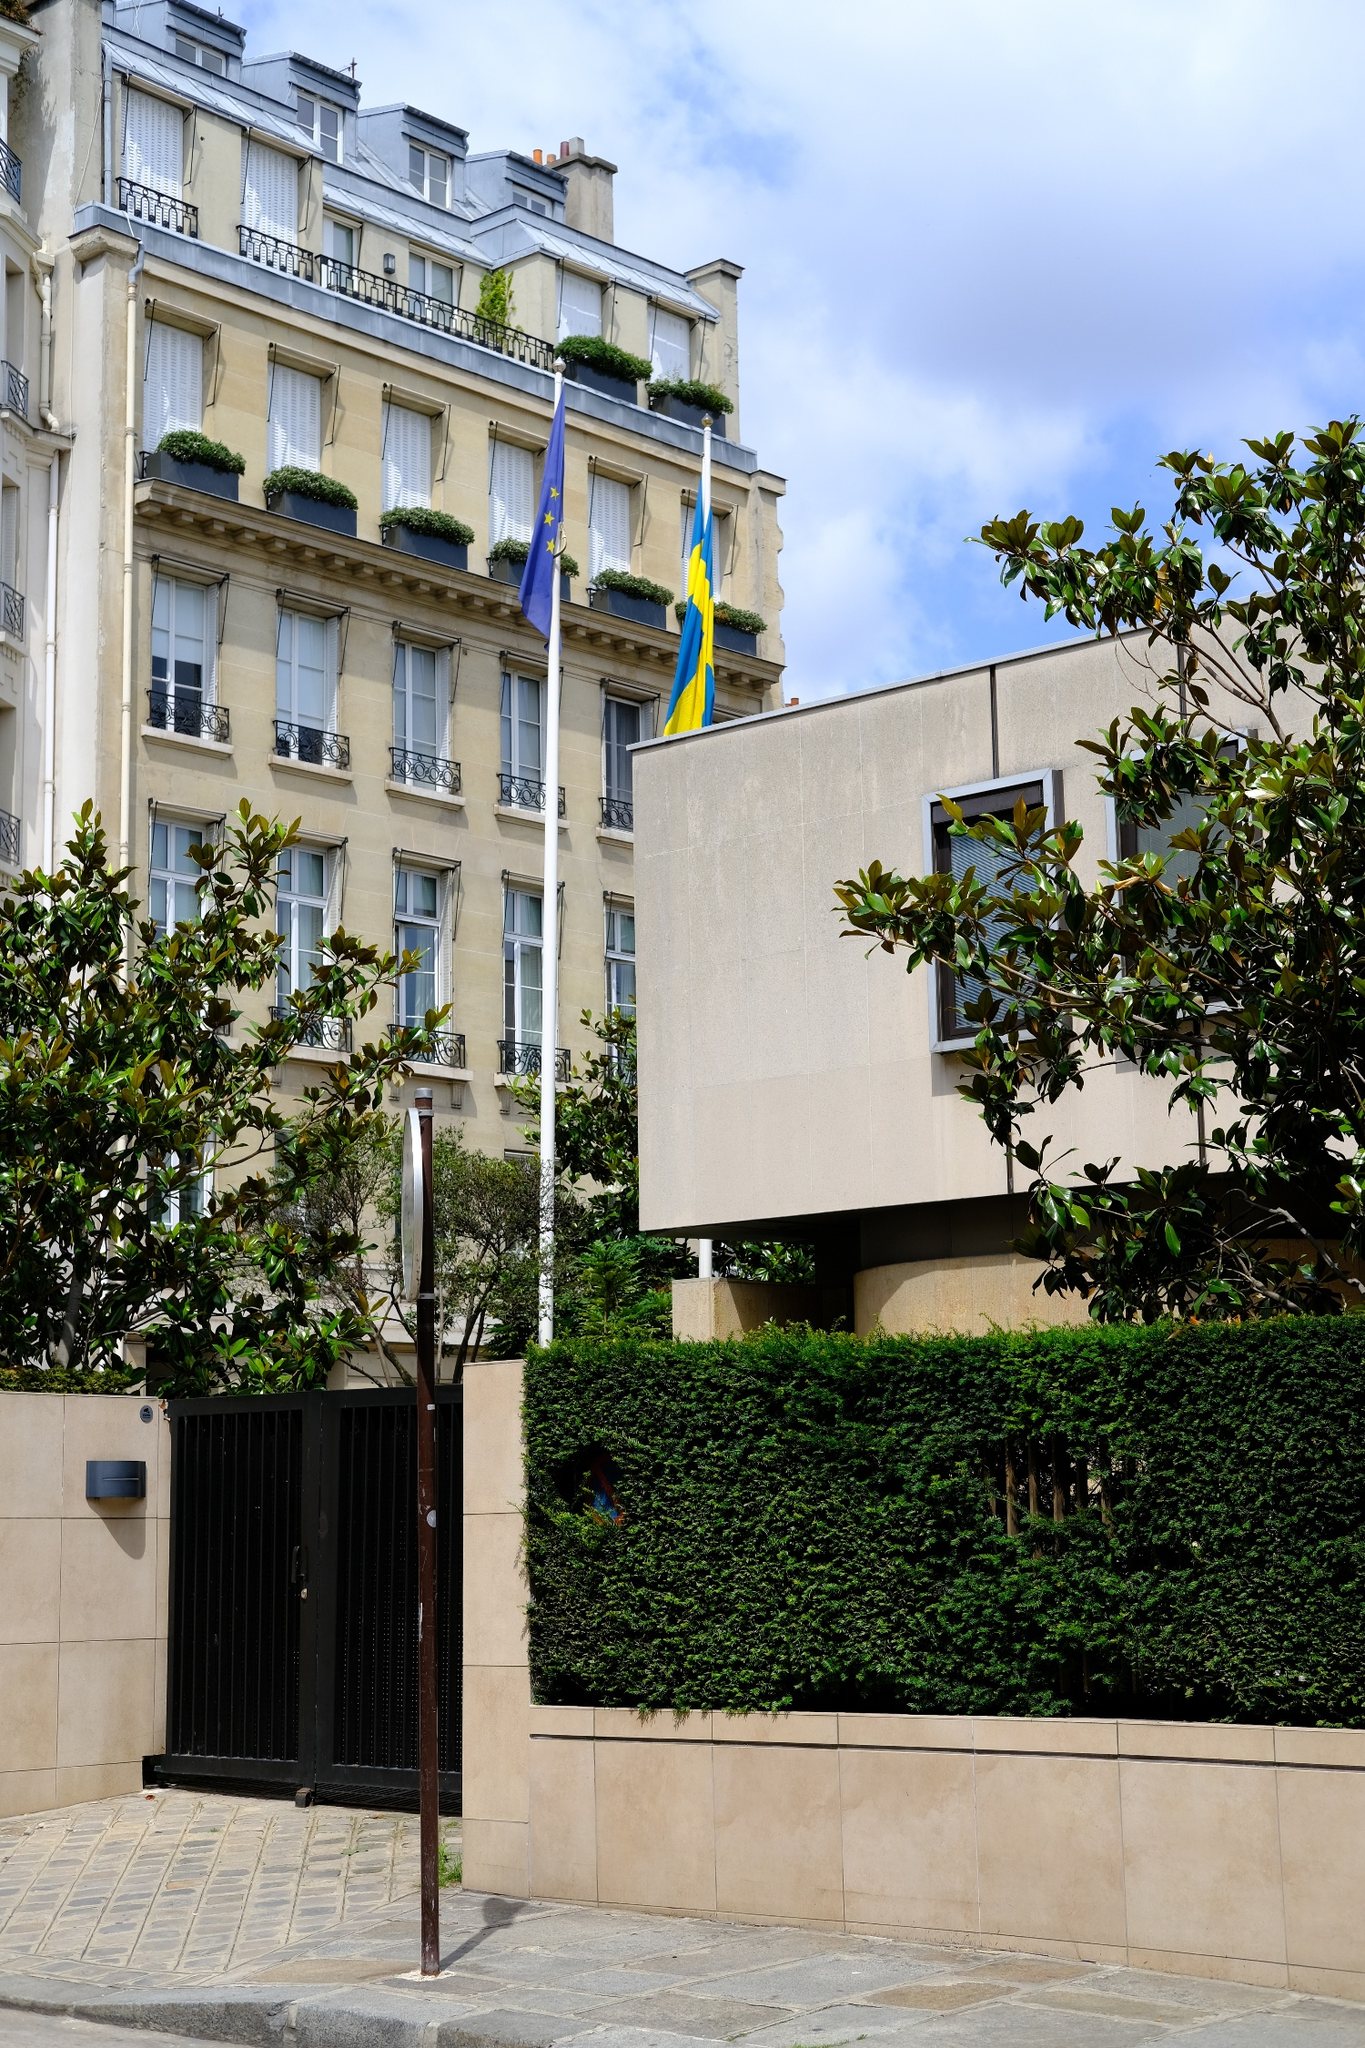Can you describe the flags seen in the image? Certainly! In the image, there are two flags prominently displayed in front of a stately beige building. The first flag is of the European Union, characterized by a circle of 12 gold stars on a blue background. These stars symbolize unity, solidarity, and harmony among the peoples of Europe. Beside it, the second flag is the Swedish flag, featuring a yellow or gold Nordic cross that extends to the edges on a blue field. The cross represents Christianity, which is traditionally linked with many European national flags, and blue and yellow are the Swedish national colors. 